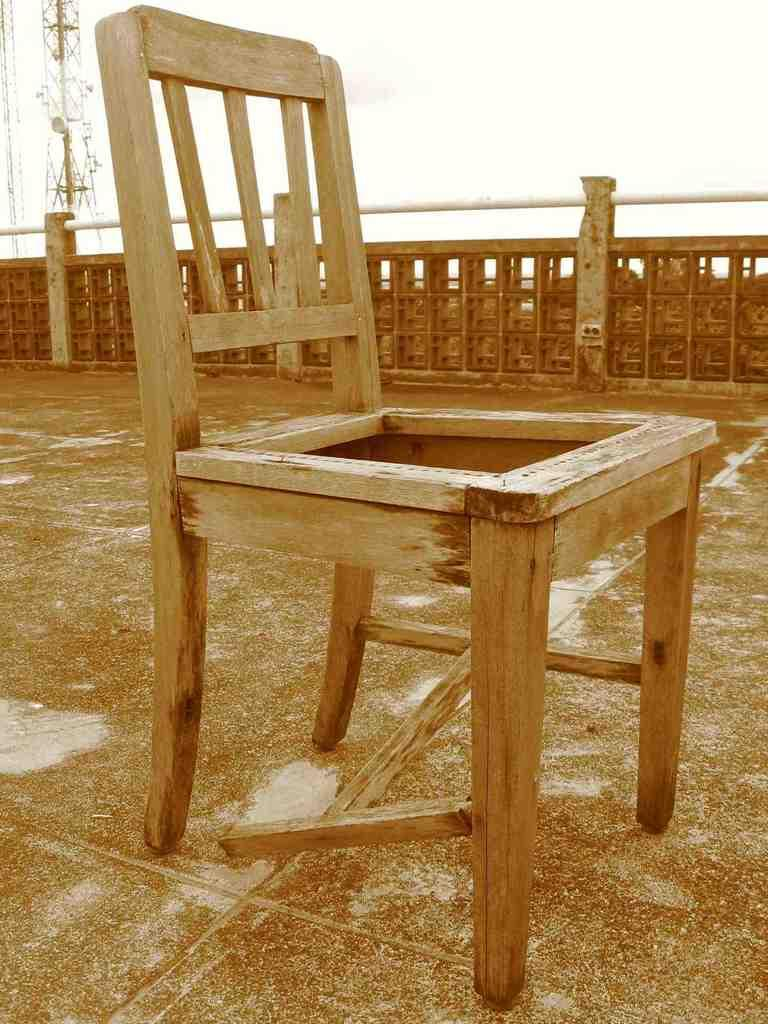What type of chair is in the image? There is a wooden chair in the image. What other structures can be seen in the image? There is a fence and a current pole in the image. What natural element is visible in the image? Water is visible in the image. What is visible at the top of the image? The sky is visible at the top of the image. Can you tell me how many seeds are planted in the cabbage in the image? There is no cabbage or seeds present in the image. What type of copy is being made in the image? There is no copying or duplication activity depicted in the image. 